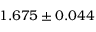Convert formula to latex. <formula><loc_0><loc_0><loc_500><loc_500>1 . 6 7 5 \pm 0 . 0 4 4</formula> 